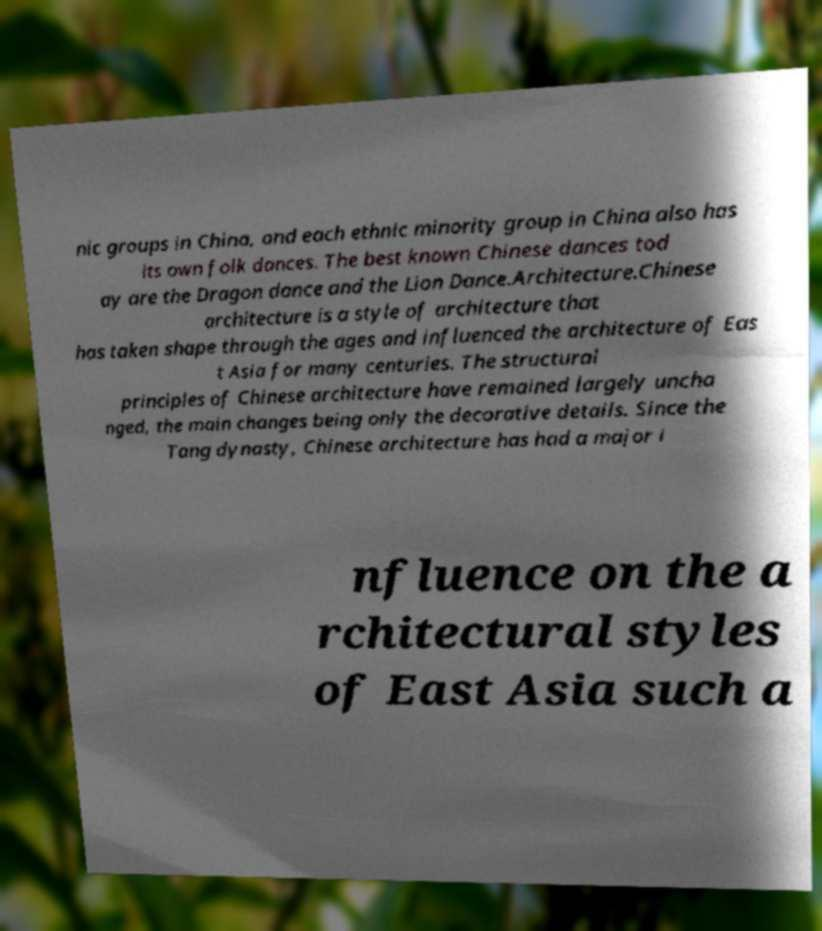Could you assist in decoding the text presented in this image and type it out clearly? nic groups in China, and each ethnic minority group in China also has its own folk dances. The best known Chinese dances tod ay are the Dragon dance and the Lion Dance.Architecture.Chinese architecture is a style of architecture that has taken shape through the ages and influenced the architecture of Eas t Asia for many centuries. The structural principles of Chinese architecture have remained largely uncha nged, the main changes being only the decorative details. Since the Tang dynasty, Chinese architecture has had a major i nfluence on the a rchitectural styles of East Asia such a 